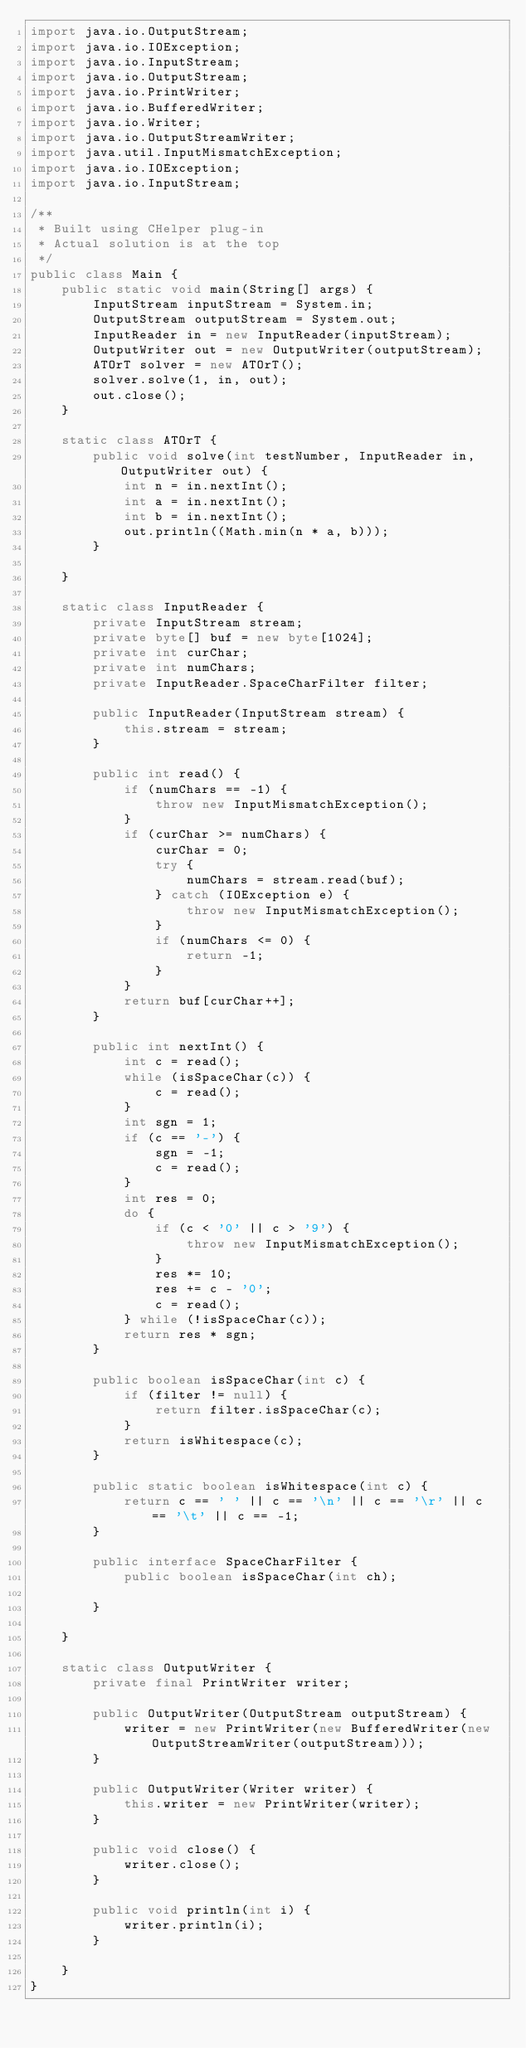<code> <loc_0><loc_0><loc_500><loc_500><_Java_>import java.io.OutputStream;
import java.io.IOException;
import java.io.InputStream;
import java.io.OutputStream;
import java.io.PrintWriter;
import java.io.BufferedWriter;
import java.io.Writer;
import java.io.OutputStreamWriter;
import java.util.InputMismatchException;
import java.io.IOException;
import java.io.InputStream;

/**
 * Built using CHelper plug-in
 * Actual solution is at the top
 */
public class Main {
    public static void main(String[] args) {
        InputStream inputStream = System.in;
        OutputStream outputStream = System.out;
        InputReader in = new InputReader(inputStream);
        OutputWriter out = new OutputWriter(outputStream);
        ATOrT solver = new ATOrT();
        solver.solve(1, in, out);
        out.close();
    }

    static class ATOrT {
        public void solve(int testNumber, InputReader in, OutputWriter out) {
            int n = in.nextInt();
            int a = in.nextInt();
            int b = in.nextInt();
            out.println((Math.min(n * a, b)));
        }

    }

    static class InputReader {
        private InputStream stream;
        private byte[] buf = new byte[1024];
        private int curChar;
        private int numChars;
        private InputReader.SpaceCharFilter filter;

        public InputReader(InputStream stream) {
            this.stream = stream;
        }

        public int read() {
            if (numChars == -1) {
                throw new InputMismatchException();
            }
            if (curChar >= numChars) {
                curChar = 0;
                try {
                    numChars = stream.read(buf);
                } catch (IOException e) {
                    throw new InputMismatchException();
                }
                if (numChars <= 0) {
                    return -1;
                }
            }
            return buf[curChar++];
        }

        public int nextInt() {
            int c = read();
            while (isSpaceChar(c)) {
                c = read();
            }
            int sgn = 1;
            if (c == '-') {
                sgn = -1;
                c = read();
            }
            int res = 0;
            do {
                if (c < '0' || c > '9') {
                    throw new InputMismatchException();
                }
                res *= 10;
                res += c - '0';
                c = read();
            } while (!isSpaceChar(c));
            return res * sgn;
        }

        public boolean isSpaceChar(int c) {
            if (filter != null) {
                return filter.isSpaceChar(c);
            }
            return isWhitespace(c);
        }

        public static boolean isWhitespace(int c) {
            return c == ' ' || c == '\n' || c == '\r' || c == '\t' || c == -1;
        }

        public interface SpaceCharFilter {
            public boolean isSpaceChar(int ch);

        }

    }

    static class OutputWriter {
        private final PrintWriter writer;

        public OutputWriter(OutputStream outputStream) {
            writer = new PrintWriter(new BufferedWriter(new OutputStreamWriter(outputStream)));
        }

        public OutputWriter(Writer writer) {
            this.writer = new PrintWriter(writer);
        }

        public void close() {
            writer.close();
        }

        public void println(int i) {
            writer.println(i);
        }

    }
}

</code> 